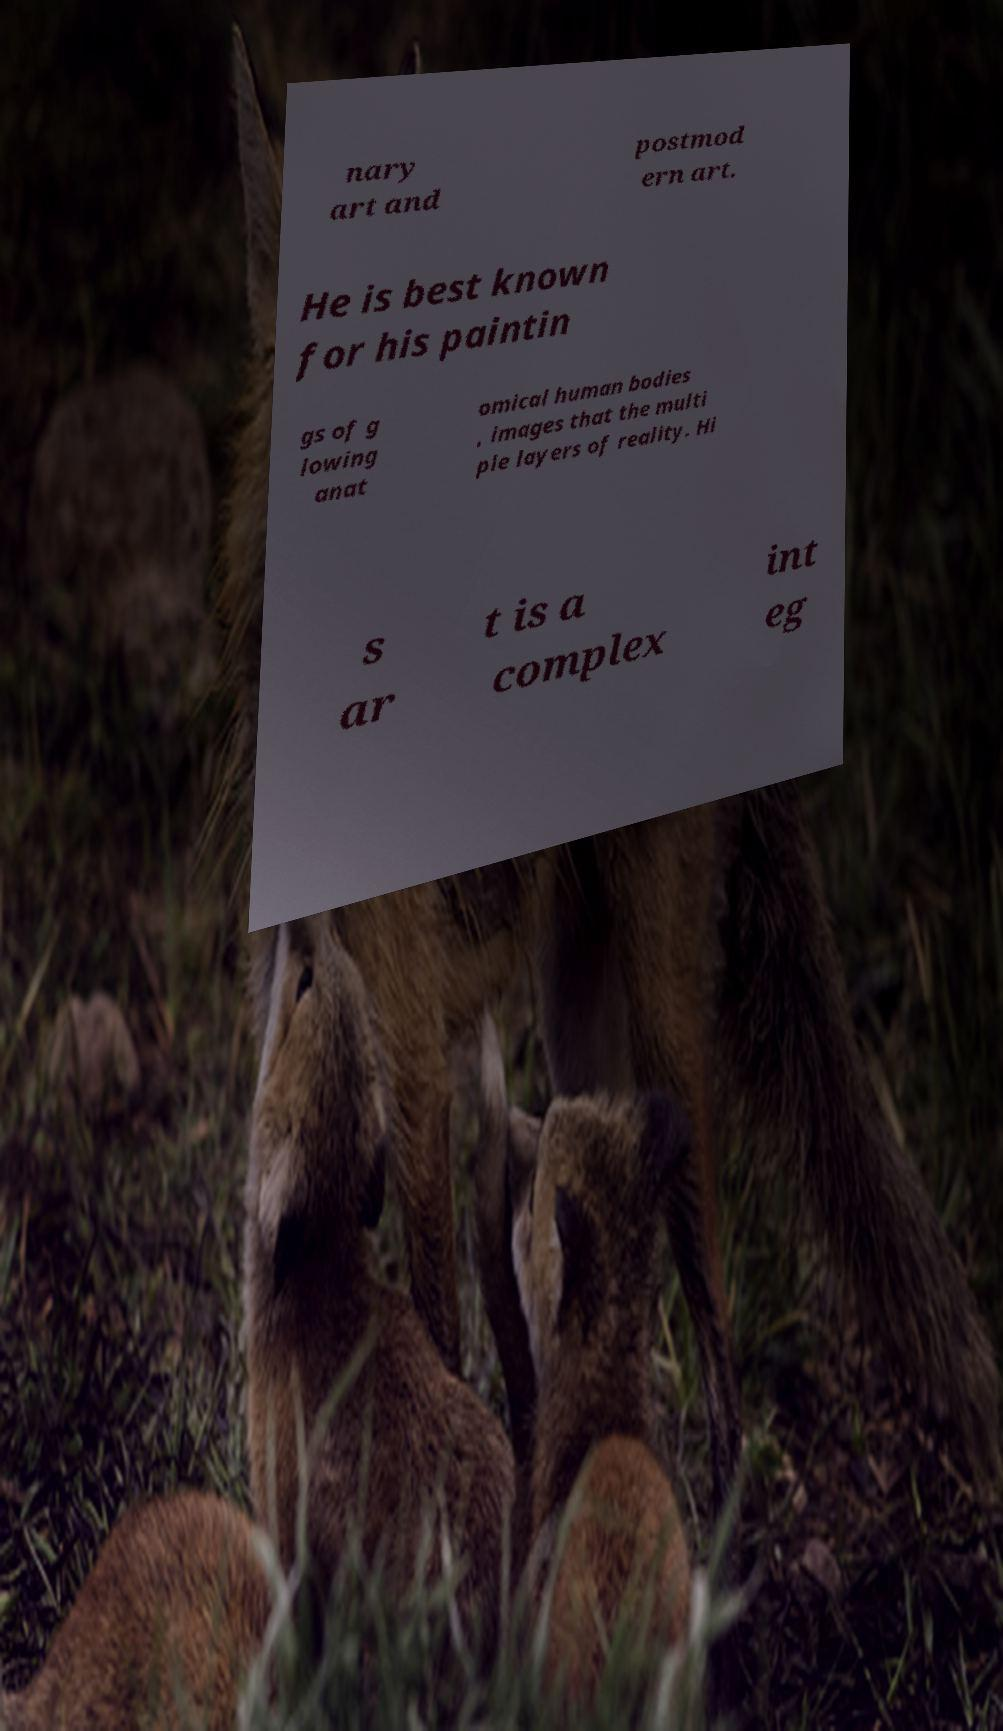Could you assist in decoding the text presented in this image and type it out clearly? nary art and postmod ern art. He is best known for his paintin gs of g lowing anat omical human bodies , images that the multi ple layers of reality. Hi s ar t is a complex int eg 